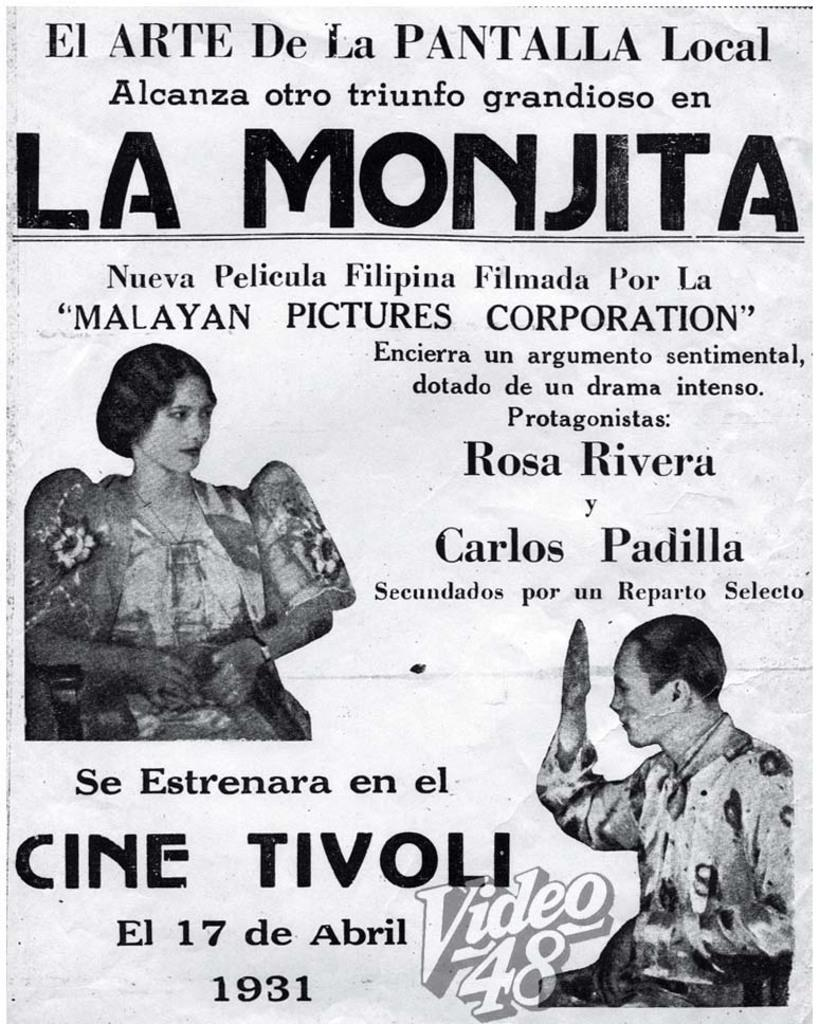What is depicted in the image? There is a drawing of a woman in the image. What is the woman doing in the drawing? The woman appears to be sitting on a chair in the drawing. Are there any other people depicted in the image? Yes, there is a drawing of a person in the image. What else can be seen on the image? Text is written on the image. How many cherries are on the rod in the image? There is no rod or cherries present in the image. What type of sugar is used to draw the person in the image? The image is a drawing, not made of sugar, so this question is not applicable. 